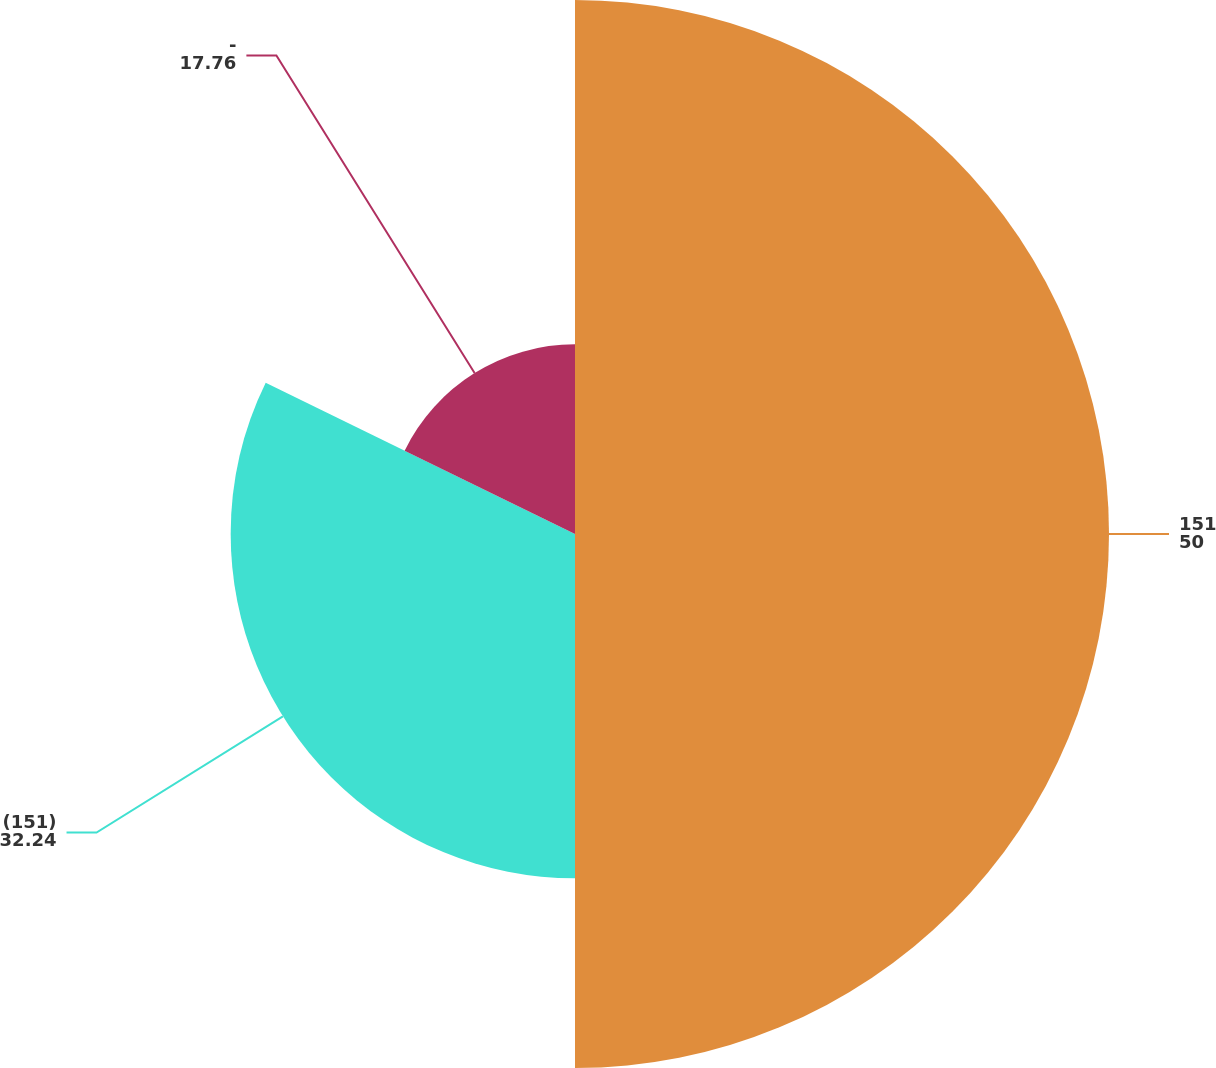Convert chart to OTSL. <chart><loc_0><loc_0><loc_500><loc_500><pie_chart><fcel>151<fcel>(151)<fcel>-<nl><fcel>50.0%<fcel>32.24%<fcel>17.76%<nl></chart> 